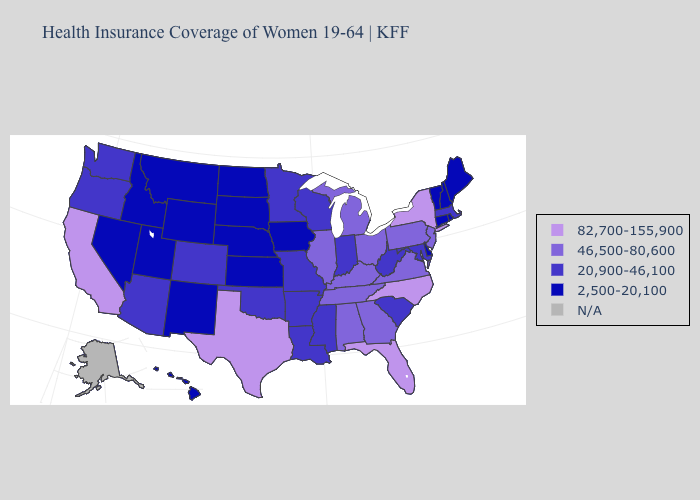Name the states that have a value in the range 20,900-46,100?
Quick response, please. Arizona, Arkansas, Colorado, Indiana, Louisiana, Maryland, Massachusetts, Minnesota, Mississippi, Missouri, Oklahoma, Oregon, South Carolina, Washington, West Virginia, Wisconsin. Which states hav the highest value in the MidWest?
Keep it brief. Illinois, Michigan, Ohio. Name the states that have a value in the range N/A?
Give a very brief answer. Alaska. Does Arizona have the lowest value in the USA?
Be succinct. No. What is the value of Mississippi?
Give a very brief answer. 20,900-46,100. Name the states that have a value in the range 46,500-80,600?
Give a very brief answer. Alabama, Georgia, Illinois, Kentucky, Michigan, New Jersey, Ohio, Pennsylvania, Tennessee, Virginia. What is the value of Minnesota?
Be succinct. 20,900-46,100. Name the states that have a value in the range 82,700-155,900?
Short answer required. California, Florida, New York, North Carolina, Texas. What is the highest value in the West ?
Write a very short answer. 82,700-155,900. How many symbols are there in the legend?
Answer briefly. 5. What is the value of Delaware?
Concise answer only. 2,500-20,100. Does New York have the highest value in the USA?
Answer briefly. Yes. What is the value of Minnesota?
Concise answer only. 20,900-46,100. Does the first symbol in the legend represent the smallest category?
Keep it brief. No. Which states have the highest value in the USA?
Short answer required. California, Florida, New York, North Carolina, Texas. 